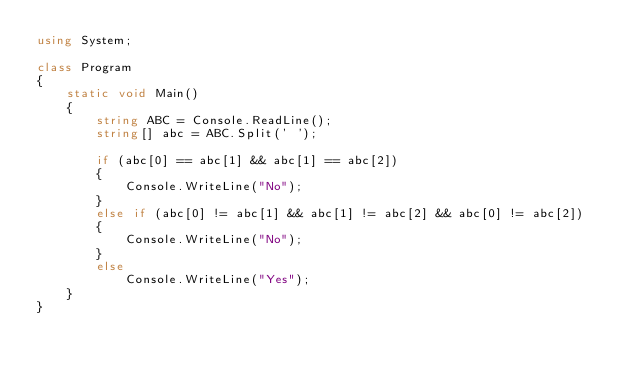Convert code to text. <code><loc_0><loc_0><loc_500><loc_500><_C#_>using System;

class Program
{
    static void Main()
    {
        string ABC = Console.ReadLine();
        string[] abc = ABC.Split(' ');

        if (abc[0] == abc[1] && abc[1] == abc[2])
        {
            Console.WriteLine("No");
        }
        else if (abc[0] != abc[1] && abc[1] != abc[2] && abc[0] != abc[2])
        {
            Console.WriteLine("No");
        }
        else
            Console.WriteLine("Yes");
    }
}</code> 